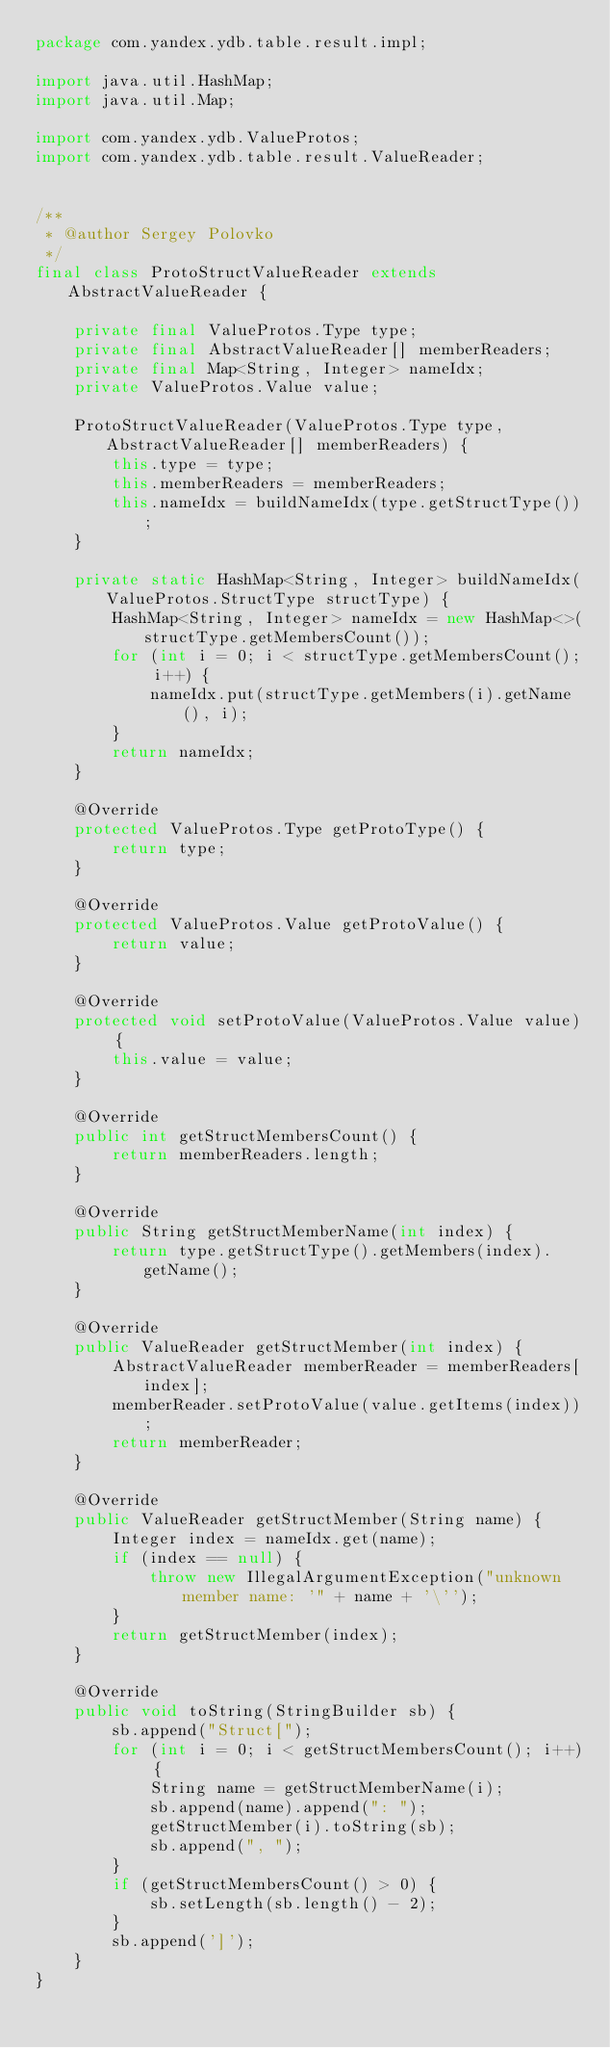<code> <loc_0><loc_0><loc_500><loc_500><_Java_>package com.yandex.ydb.table.result.impl;

import java.util.HashMap;
import java.util.Map;

import com.yandex.ydb.ValueProtos;
import com.yandex.ydb.table.result.ValueReader;


/**
 * @author Sergey Polovko
 */
final class ProtoStructValueReader extends AbstractValueReader {

    private final ValueProtos.Type type;
    private final AbstractValueReader[] memberReaders;
    private final Map<String, Integer> nameIdx;
    private ValueProtos.Value value;

    ProtoStructValueReader(ValueProtos.Type type, AbstractValueReader[] memberReaders) {
        this.type = type;
        this.memberReaders = memberReaders;
        this.nameIdx = buildNameIdx(type.getStructType());
    }

    private static HashMap<String, Integer> buildNameIdx(ValueProtos.StructType structType) {
        HashMap<String, Integer> nameIdx = new HashMap<>(structType.getMembersCount());
        for (int i = 0; i < structType.getMembersCount(); i++) {
            nameIdx.put(structType.getMembers(i).getName(), i);
        }
        return nameIdx;
    }

    @Override
    protected ValueProtos.Type getProtoType() {
        return type;
    }

    @Override
    protected ValueProtos.Value getProtoValue() {
        return value;
    }

    @Override
    protected void setProtoValue(ValueProtos.Value value) {
        this.value = value;
    }

    @Override
    public int getStructMembersCount() {
        return memberReaders.length;
    }

    @Override
    public String getStructMemberName(int index) {
        return type.getStructType().getMembers(index).getName();
    }

    @Override
    public ValueReader getStructMember(int index) {
        AbstractValueReader memberReader = memberReaders[index];
        memberReader.setProtoValue(value.getItems(index));
        return memberReader;
    }

    @Override
    public ValueReader getStructMember(String name) {
        Integer index = nameIdx.get(name);
        if (index == null) {
            throw new IllegalArgumentException("unknown member name: '" + name + '\'');
        }
        return getStructMember(index);
    }

    @Override
    public void toString(StringBuilder sb) {
        sb.append("Struct[");
        for (int i = 0; i < getStructMembersCount(); i++) {
            String name = getStructMemberName(i);
            sb.append(name).append(": ");
            getStructMember(i).toString(sb);
            sb.append(", ");
        }
        if (getStructMembersCount() > 0) {
            sb.setLength(sb.length() - 2);
        }
        sb.append(']');
    }
}
</code> 